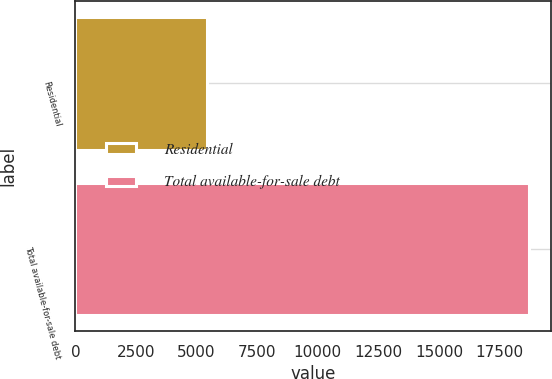Convert chart to OTSL. <chart><loc_0><loc_0><loc_500><loc_500><bar_chart><fcel>Residential<fcel>Total available-for-sale debt<nl><fcel>5439<fcel>18702<nl></chart> 